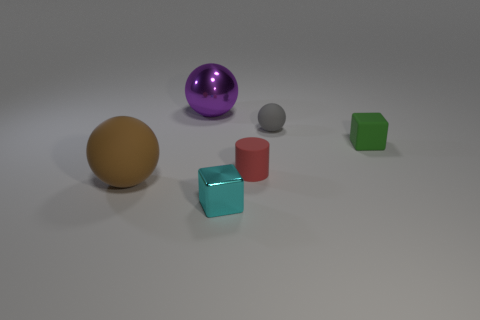Add 3 small blue objects. How many objects exist? 9 Subtract all cylinders. How many objects are left? 5 Add 2 things. How many things exist? 8 Subtract 0 purple cubes. How many objects are left? 6 Subtract all shiny cubes. Subtract all tiny matte things. How many objects are left? 2 Add 2 tiny red cylinders. How many tiny red cylinders are left? 3 